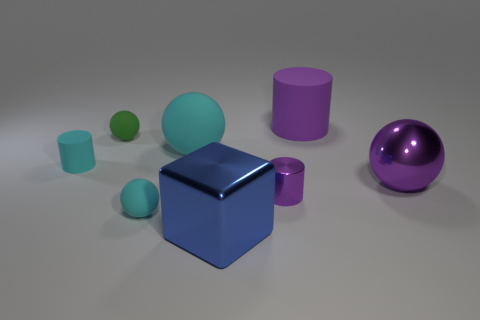What could be the purpose of arranging these objects like this? This arrangement could be purposed for a variety of reasons. It could be a basic 3D composition study focusing on the interplay between different geometric forms, colors, and materials. Alternatively, it might serve as a visual demonstration for educational purposes, perhaps in the fields of art, design, or even physics to discuss topics such as light, shadow, and reflection. 